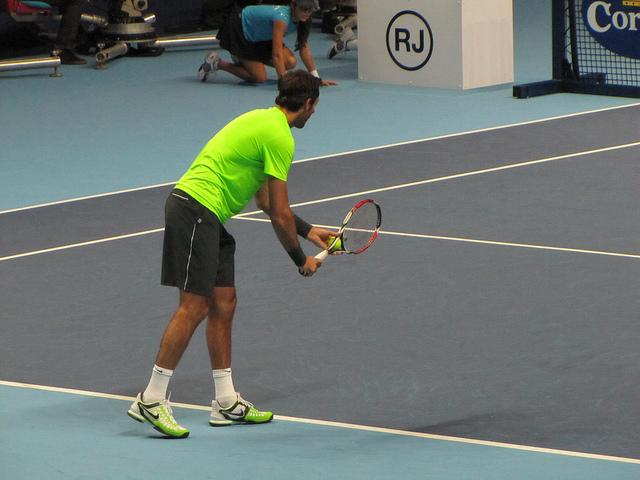What is the job of the girl who is knelt down in the front of the picture? Please explain your reasoning. collect ball. She collects the balls. 